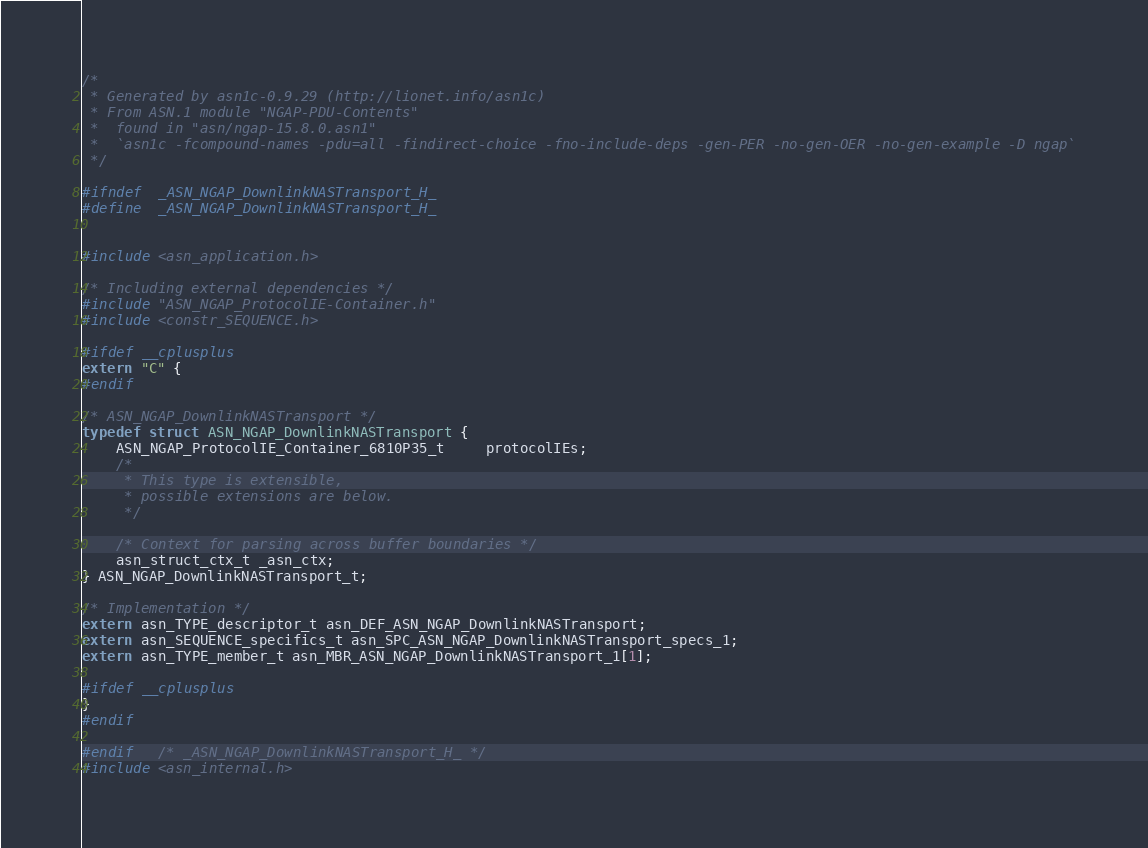Convert code to text. <code><loc_0><loc_0><loc_500><loc_500><_C_>/*
 * Generated by asn1c-0.9.29 (http://lionet.info/asn1c)
 * From ASN.1 module "NGAP-PDU-Contents"
 * 	found in "asn/ngap-15.8.0.asn1"
 * 	`asn1c -fcompound-names -pdu=all -findirect-choice -fno-include-deps -gen-PER -no-gen-OER -no-gen-example -D ngap`
 */

#ifndef	_ASN_NGAP_DownlinkNASTransport_H_
#define	_ASN_NGAP_DownlinkNASTransport_H_


#include <asn_application.h>

/* Including external dependencies */
#include "ASN_NGAP_ProtocolIE-Container.h"
#include <constr_SEQUENCE.h>

#ifdef __cplusplus
extern "C" {
#endif

/* ASN_NGAP_DownlinkNASTransport */
typedef struct ASN_NGAP_DownlinkNASTransport {
	ASN_NGAP_ProtocolIE_Container_6810P35_t	 protocolIEs;
	/*
	 * This type is extensible,
	 * possible extensions are below.
	 */
	
	/* Context for parsing across buffer boundaries */
	asn_struct_ctx_t _asn_ctx;
} ASN_NGAP_DownlinkNASTransport_t;

/* Implementation */
extern asn_TYPE_descriptor_t asn_DEF_ASN_NGAP_DownlinkNASTransport;
extern asn_SEQUENCE_specifics_t asn_SPC_ASN_NGAP_DownlinkNASTransport_specs_1;
extern asn_TYPE_member_t asn_MBR_ASN_NGAP_DownlinkNASTransport_1[1];

#ifdef __cplusplus
}
#endif

#endif	/* _ASN_NGAP_DownlinkNASTransport_H_ */
#include <asn_internal.h>
</code> 